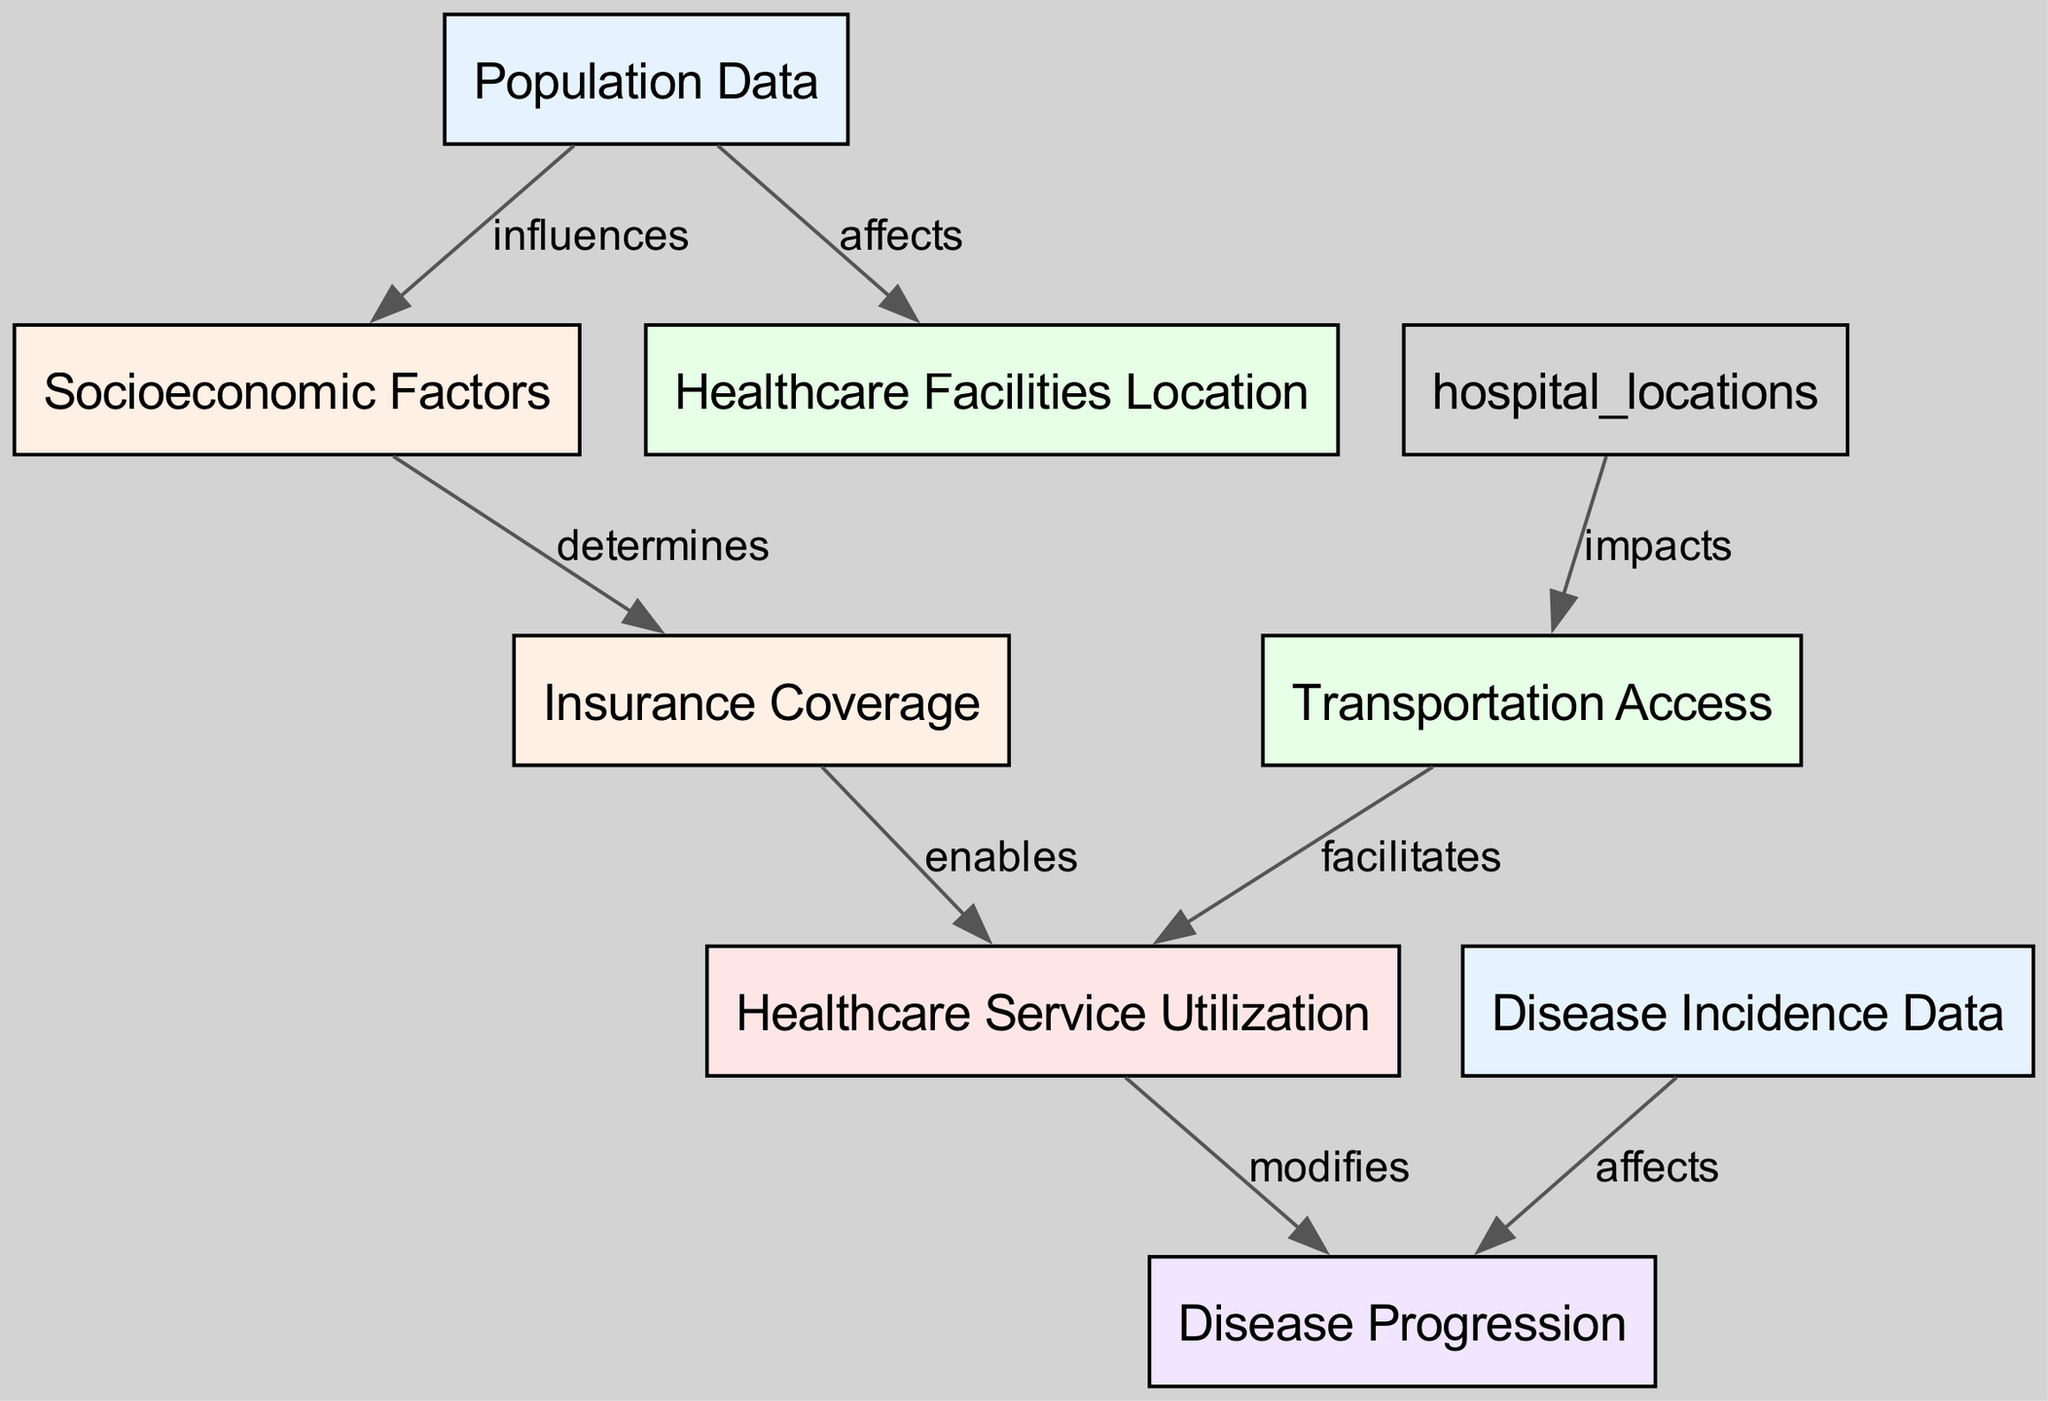What are the total number of nodes in the diagram? The nodes listed are: Population Data, Socioeconomic Factors, Healthcare Facilities Location, Insurance Coverage, Transportation Access, Healthcare Service Utilization, Disease Incidence Data, and Disease Progression. Counting these gives a total of 8 nodes.
Answer: 8 Which node represents the coverage that allows access to health services? The node labeled Insurance Coverage connects to Healthcare Service Utilization, indicating that it enables access to health services.
Answer: Insurance Coverage How many edges are there connecting these nodes? The edges listed in the data represent connections between the nodes. Counting these gives a total of 7 edges.
Answer: 7 What type of relationship exists between Healthcare Service Utilization and Disease Progression? The edge from Healthcare Service Utilization to Disease Progression is labeled "modifies," indicating that service utilization has an impact on how diseases progress.
Answer: modifies Which node directly influences the Insurance Coverage node? The Socioeconomic Factors node has an edge directed towards Insurance Coverage, indicating that it determines the insurance coverage available to the population.
Answer: Socioeconomic Factors What impact does Transportation Access have on Healthcare Service Utilization? The edge from Transportation Access to Healthcare Service Utilization is labeled "facilitates," suggesting that improved transportation access helps ensure that more healthcare services are utilized.
Answer: facilitates Which factors contribute to the progression of disease according to the diagram? The two nodes that affect Disease Progression are Healthcare Service Utilization (modifies) and Disease Incidence Data (affects), linking the healthcare dynamics and incidence of disease to progression.
Answer: Healthcare Service Utilization, Disease Incidence Data What is the relationship between Population Data and Healthcare Facilities Location? The edge from Population Data to Healthcare Facilities Location is labeled "affects," indicating that the characteristics of the population affect where healthcare facilities are located.
Answer: affects 